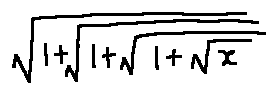Convert formula to latex. <formula><loc_0><loc_0><loc_500><loc_500>\sqrt { 1 + \sqrt { 1 + \sqrt { 1 + \sqrt { x } } } }</formula> 